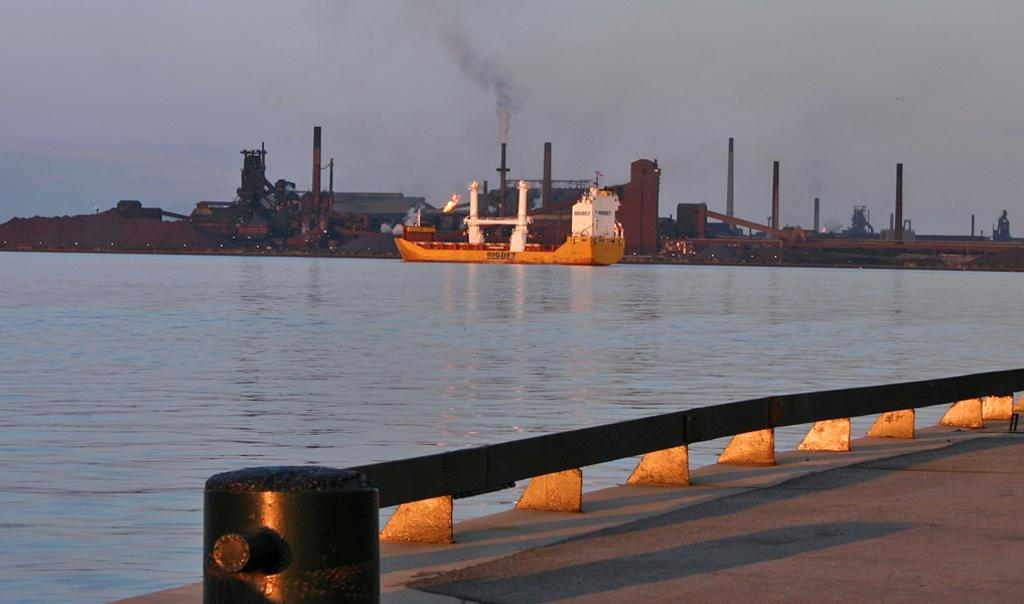What is the main subject of the image? The main subject of the image is a boat. Where is the boat located in the image? The boat is on the water. What can be seen in the background of the image? There are buildings, poles, and a bridge visible in the background of the image. Are there any fairies flying around the boat in the image? There are no fairies present in the image. Can you tell me how many people are on the boat in the image? The image does not show any people on the boat, so it is not possible to determine the number of people. 